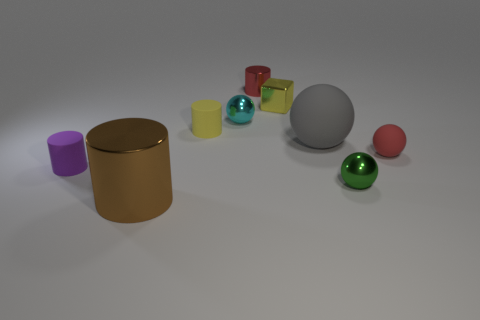What number of objects are either matte cylinders behind the large gray ball or small cyan metal spheres?
Give a very brief answer. 2. There is a shiny cylinder in front of the small red thing that is behind the red rubber thing; are there any tiny cylinders that are behind it?
Give a very brief answer. Yes. How many tiny shiny objects are there?
Ensure brevity in your answer.  4. What number of things are rubber cylinders behind the purple cylinder or objects that are in front of the tiny yellow rubber cylinder?
Make the answer very short. 6. There is a red thing right of the red shiny thing; is its size the same as the small cube?
Offer a very short reply. Yes. There is a yellow matte object that is the same shape as the purple object; what size is it?
Keep it short and to the point. Small. There is another object that is the same size as the gray thing; what is its material?
Provide a succinct answer. Metal. What is the material of the brown object that is the same shape as the yellow rubber object?
Your answer should be very brief. Metal. How many other objects are the same size as the gray rubber object?
Keep it short and to the point. 1. There is a matte ball that is the same color as the tiny metallic cylinder; what size is it?
Your answer should be compact. Small. 